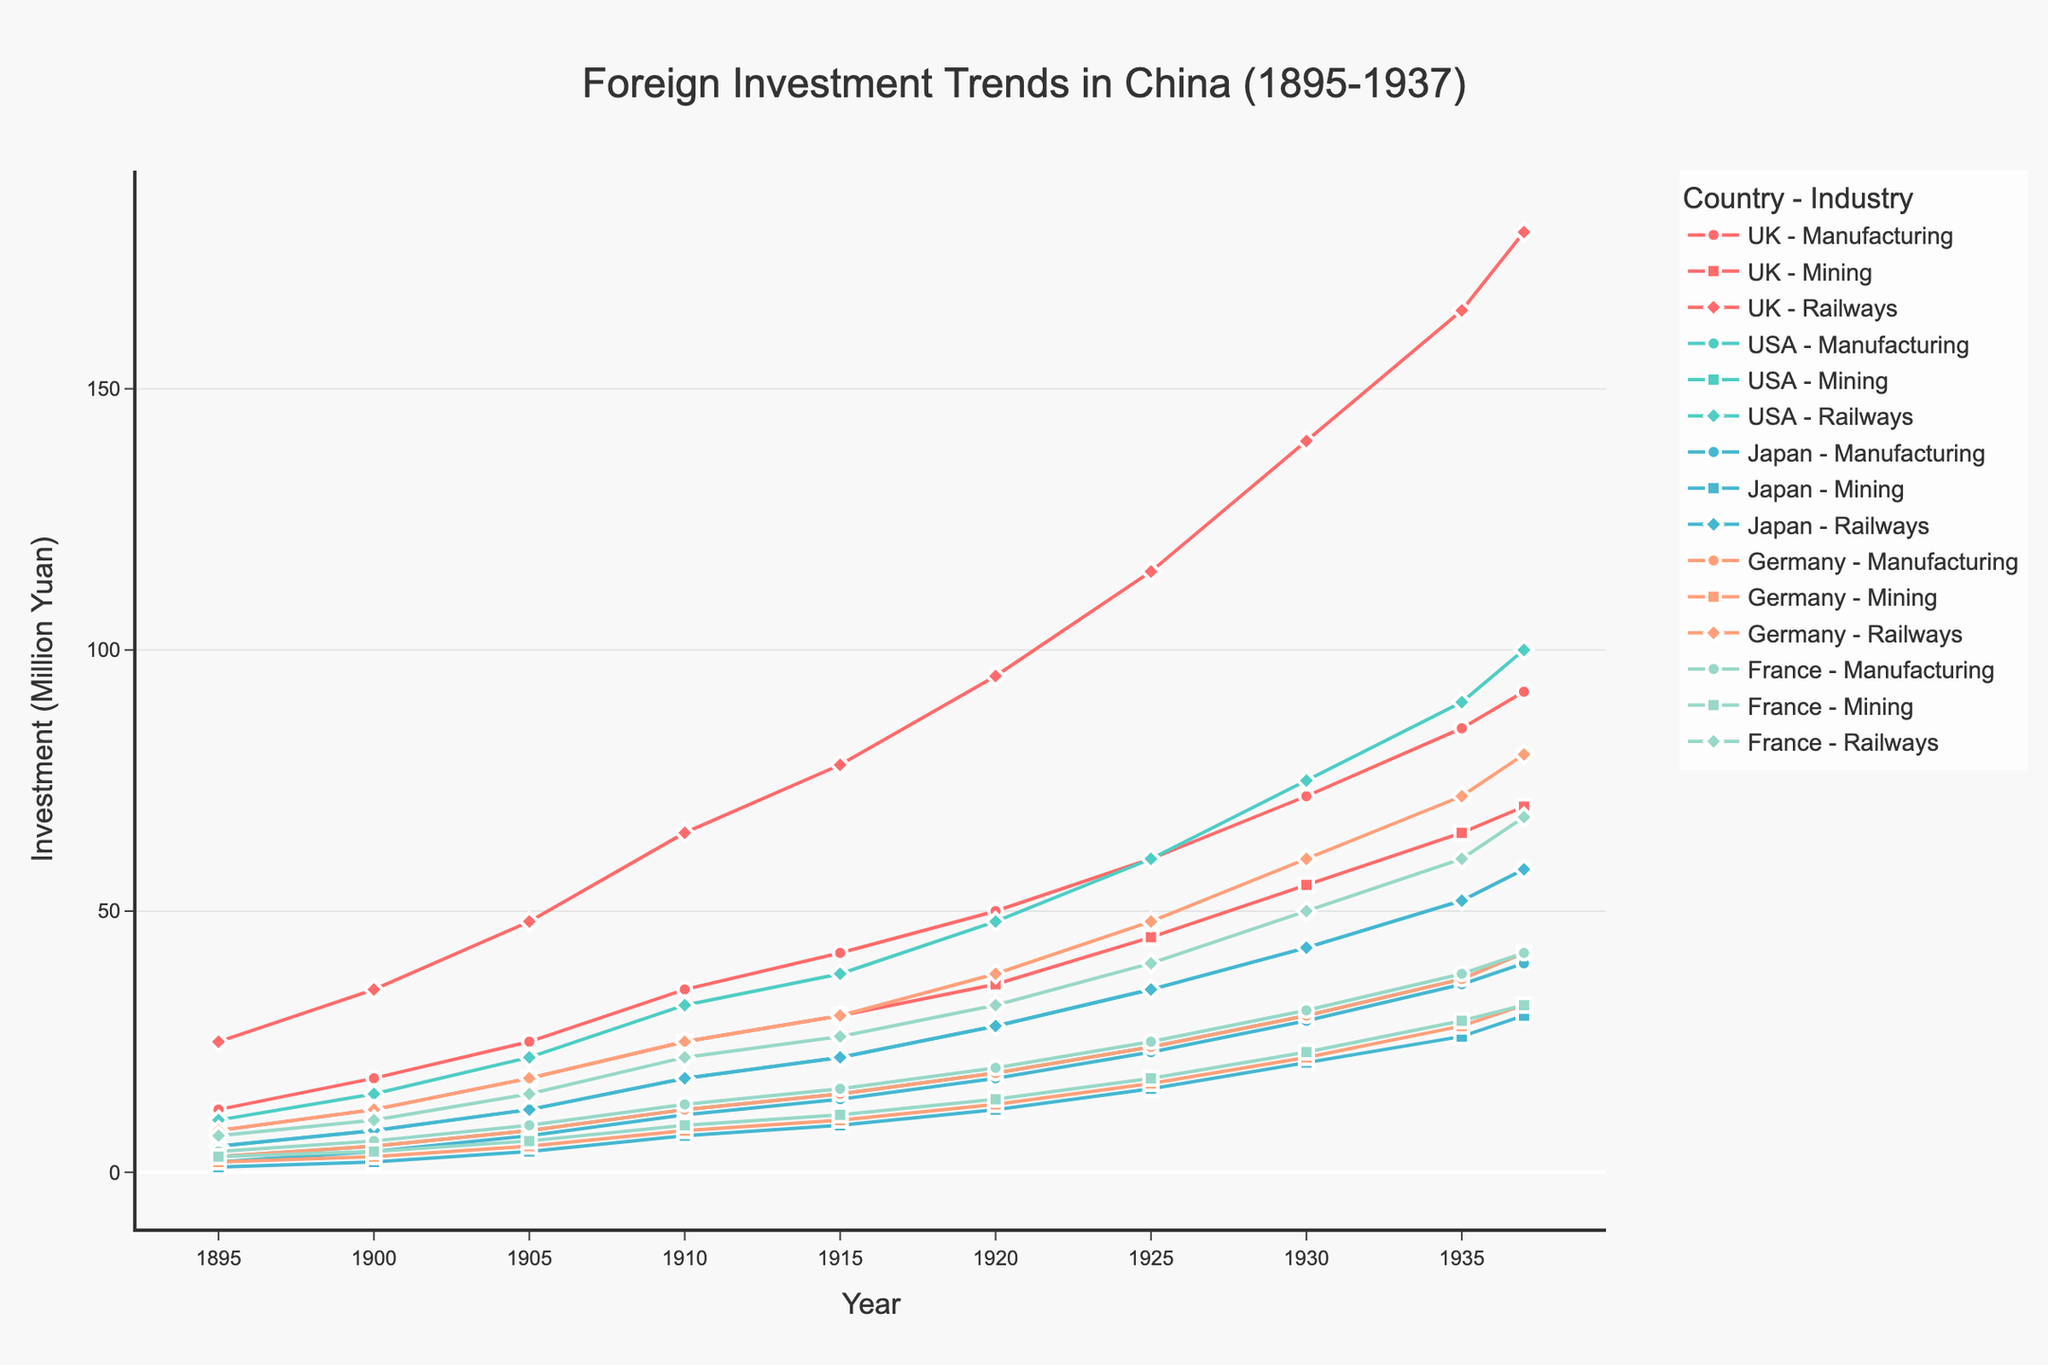Which country had the highest investment in railways in 1937? Look at the data points for each country labeled as "Railways" for the year 1937. The highest value is found under the UK with 180 million Yuan.
Answer: UK Between 1895 and 1937, which industry had the highest growth in investment from the UK? Calculate the difference in investment for each industry (Manufacturing, Mining, Railways) in the UK between 1895 and 1937. The differences are 92-12=80 (Manufacturing), 70-8=62 (Mining), and 180-25=155 (Railways). The railway industry had the highest growth.
Answer: Railways Compare the total investment by the USA in 1920 and 1937. Which year had a higher total investment, and by how much? Sum the investment in all industries for the USA in 1920 (28+19+48) and 1937 (58+42+100). The total amounts are 95 million Yuan (1920) and 200 million Yuan (1937). Calculate the difference: 200 - 95 = 105 million Yuan. The year 1937 had a higher total investment by 105 million Yuan.
Answer: 1937, by 105 million Yuan What is the average investment in Manufacturing by Germany over the period 1895-1937? Sum the investment values for Germany in Manufacturing from 1895 to 1937 (3+5+8+12+15+19+24+30+37+42) and divide by the number of years (10). The sum is 195, and the average is 195/10 = 19.5 million Yuan.
Answer: 19.5 million Yuan Which industry saw a steeper increase in investment by Japan from 1920 to 1937: Mining or Railways? Calculate the increase in investment for Japan in Mining (30-12=18) and Railways (58-28=30) from 1920 to 1937. The steeper increase is in Railways with a growth of 30 million Yuan.
Answer: Railways Among France’s industries, which one had the slowest growth rate from 1895 to 1937? Calculate the increase in investment from 1895 to 1937 for each industry in France: Manufacturing (42-4=38), Mining (32-3=29), and Railways (68-7=61). The slowest growth rate is found in Mining.
Answer: Mining In what year did the USA surpass the UK in total manufacturing investment for the first time? Compare the investment values in Manufacturing for the USA and UK for each year. In 1935, USA (52) surpassed UK (42) for the first time.
Answer: 1935 What is the overall trend in France's investment in railways over the entire period? Examine the data points for France’s investment in railways over the years. The values show a consistent increase from 7 in 1895 to 68 in 1937, indicating a steady upward trend.
Answer: Upward trend How did Japan's investment in mining compare to Germany's in 1930? Check the values for Japan and Germany in the mining industry in 1930. Japan invested 21 million Yuan and Germany 22 million Yuan. Germany's investment was slightly higher.
Answer: Germany Was there a decade where the UK’s investment in manufacturing doubled? If so, which one? Check for periods where the UK’s investment in manufacturing doubles. It increased from 25 million Yuan in 1905 to 50 million Yuan in 1920, a little more than a decade, but meets the condition.
Answer: 1905-1920 